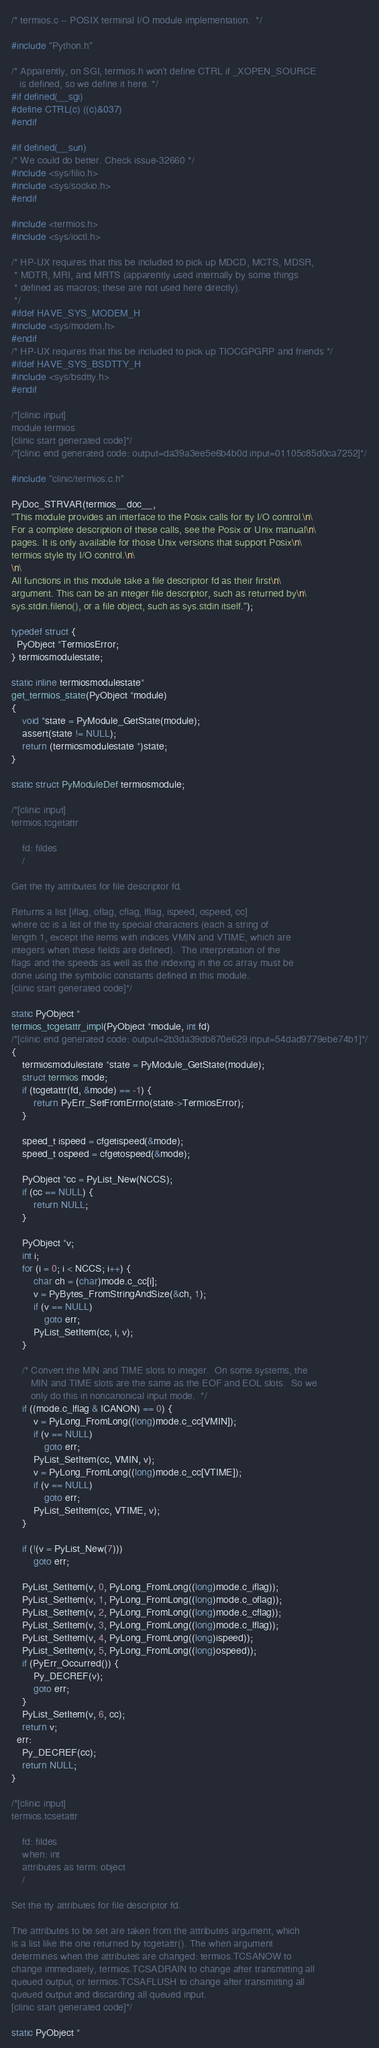Convert code to text. <code><loc_0><loc_0><loc_500><loc_500><_C_>/* termios.c -- POSIX terminal I/O module implementation.  */

#include "Python.h"

/* Apparently, on SGI, termios.h won't define CTRL if _XOPEN_SOURCE
   is defined, so we define it here. */
#if defined(__sgi)
#define CTRL(c) ((c)&037)
#endif

#if defined(__sun)
/* We could do better. Check issue-32660 */
#include <sys/filio.h>
#include <sys/sockio.h>
#endif

#include <termios.h>
#include <sys/ioctl.h>

/* HP-UX requires that this be included to pick up MDCD, MCTS, MDSR,
 * MDTR, MRI, and MRTS (apparently used internally by some things
 * defined as macros; these are not used here directly).
 */
#ifdef HAVE_SYS_MODEM_H
#include <sys/modem.h>
#endif
/* HP-UX requires that this be included to pick up TIOCGPGRP and friends */
#ifdef HAVE_SYS_BSDTTY_H
#include <sys/bsdtty.h>
#endif

/*[clinic input]
module termios
[clinic start generated code]*/
/*[clinic end generated code: output=da39a3ee5e6b4b0d input=01105c85d0ca7252]*/

#include "clinic/termios.c.h"

PyDoc_STRVAR(termios__doc__,
"This module provides an interface to the Posix calls for tty I/O control.\n\
For a complete description of these calls, see the Posix or Unix manual\n\
pages. It is only available for those Unix versions that support Posix\n\
termios style tty I/O control.\n\
\n\
All functions in this module take a file descriptor fd as their first\n\
argument. This can be an integer file descriptor, such as returned by\n\
sys.stdin.fileno(), or a file object, such as sys.stdin itself.");

typedef struct {
  PyObject *TermiosError;
} termiosmodulestate;

static inline termiosmodulestate*
get_termios_state(PyObject *module)
{
    void *state = PyModule_GetState(module);
    assert(state != NULL);
    return (termiosmodulestate *)state;
}

static struct PyModuleDef termiosmodule;

/*[clinic input]
termios.tcgetattr

    fd: fildes
    /

Get the tty attributes for file descriptor fd.

Returns a list [iflag, oflag, cflag, lflag, ispeed, ospeed, cc]
where cc is a list of the tty special characters (each a string of
length 1, except the items with indices VMIN and VTIME, which are
integers when these fields are defined).  The interpretation of the
flags and the speeds as well as the indexing in the cc array must be
done using the symbolic constants defined in this module.
[clinic start generated code]*/

static PyObject *
termios_tcgetattr_impl(PyObject *module, int fd)
/*[clinic end generated code: output=2b3da39db870e629 input=54dad9779ebe74b1]*/
{
    termiosmodulestate *state = PyModule_GetState(module);
    struct termios mode;
    if (tcgetattr(fd, &mode) == -1) {
        return PyErr_SetFromErrno(state->TermiosError);
    }

    speed_t ispeed = cfgetispeed(&mode);
    speed_t ospeed = cfgetospeed(&mode);

    PyObject *cc = PyList_New(NCCS);
    if (cc == NULL) {
        return NULL;
    }

    PyObject *v;
    int i;
    for (i = 0; i < NCCS; i++) {
        char ch = (char)mode.c_cc[i];
        v = PyBytes_FromStringAndSize(&ch, 1);
        if (v == NULL)
            goto err;
        PyList_SetItem(cc, i, v);
    }

    /* Convert the MIN and TIME slots to integer.  On some systems, the
       MIN and TIME slots are the same as the EOF and EOL slots.  So we
       only do this in noncanonical input mode.  */
    if ((mode.c_lflag & ICANON) == 0) {
        v = PyLong_FromLong((long)mode.c_cc[VMIN]);
        if (v == NULL)
            goto err;
        PyList_SetItem(cc, VMIN, v);
        v = PyLong_FromLong((long)mode.c_cc[VTIME]);
        if (v == NULL)
            goto err;
        PyList_SetItem(cc, VTIME, v);
    }

    if (!(v = PyList_New(7)))
        goto err;

    PyList_SetItem(v, 0, PyLong_FromLong((long)mode.c_iflag));
    PyList_SetItem(v, 1, PyLong_FromLong((long)mode.c_oflag));
    PyList_SetItem(v, 2, PyLong_FromLong((long)mode.c_cflag));
    PyList_SetItem(v, 3, PyLong_FromLong((long)mode.c_lflag));
    PyList_SetItem(v, 4, PyLong_FromLong((long)ispeed));
    PyList_SetItem(v, 5, PyLong_FromLong((long)ospeed));
    if (PyErr_Occurred()) {
        Py_DECREF(v);
        goto err;
    }
    PyList_SetItem(v, 6, cc);
    return v;
  err:
    Py_DECREF(cc);
    return NULL;
}

/*[clinic input]
termios.tcsetattr

    fd: fildes
    when: int
    attributes as term: object
    /

Set the tty attributes for file descriptor fd.

The attributes to be set are taken from the attributes argument, which
is a list like the one returned by tcgetattr(). The when argument
determines when the attributes are changed: termios.TCSANOW to
change immediately, termios.TCSADRAIN to change after transmitting all
queued output, or termios.TCSAFLUSH to change after transmitting all
queued output and discarding all queued input.
[clinic start generated code]*/

static PyObject *</code> 